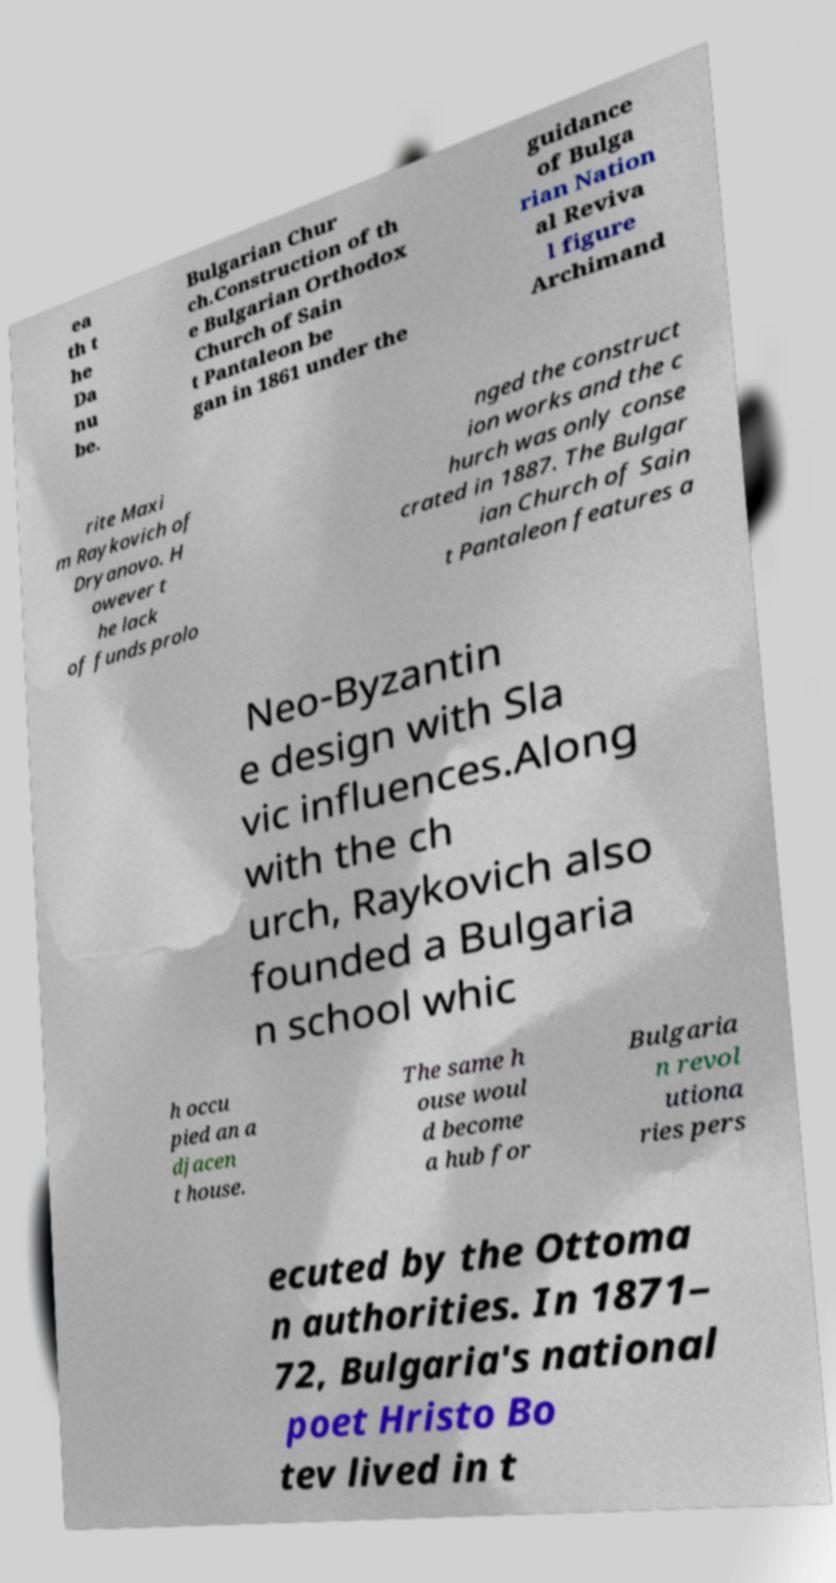Could you extract and type out the text from this image? ea th t he Da nu be. Bulgarian Chur ch.Construction of th e Bulgarian Orthodox Church of Sain t Pantaleon be gan in 1861 under the guidance of Bulga rian Nation al Reviva l figure Archimand rite Maxi m Raykovich of Dryanovo. H owever t he lack of funds prolo nged the construct ion works and the c hurch was only conse crated in 1887. The Bulgar ian Church of Sain t Pantaleon features a Neo-Byzantin e design with Sla vic influences.Along with the ch urch, Raykovich also founded a Bulgaria n school whic h occu pied an a djacen t house. The same h ouse woul d become a hub for Bulgaria n revol utiona ries pers ecuted by the Ottoma n authorities. In 1871– 72, Bulgaria's national poet Hristo Bo tev lived in t 